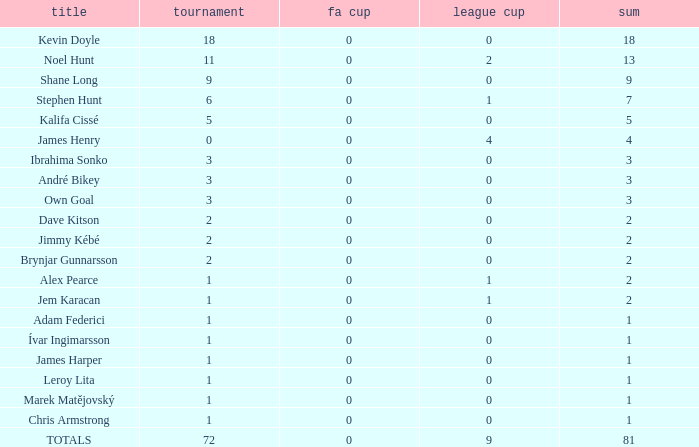How many league cup championships have a total of less than 0? None. 